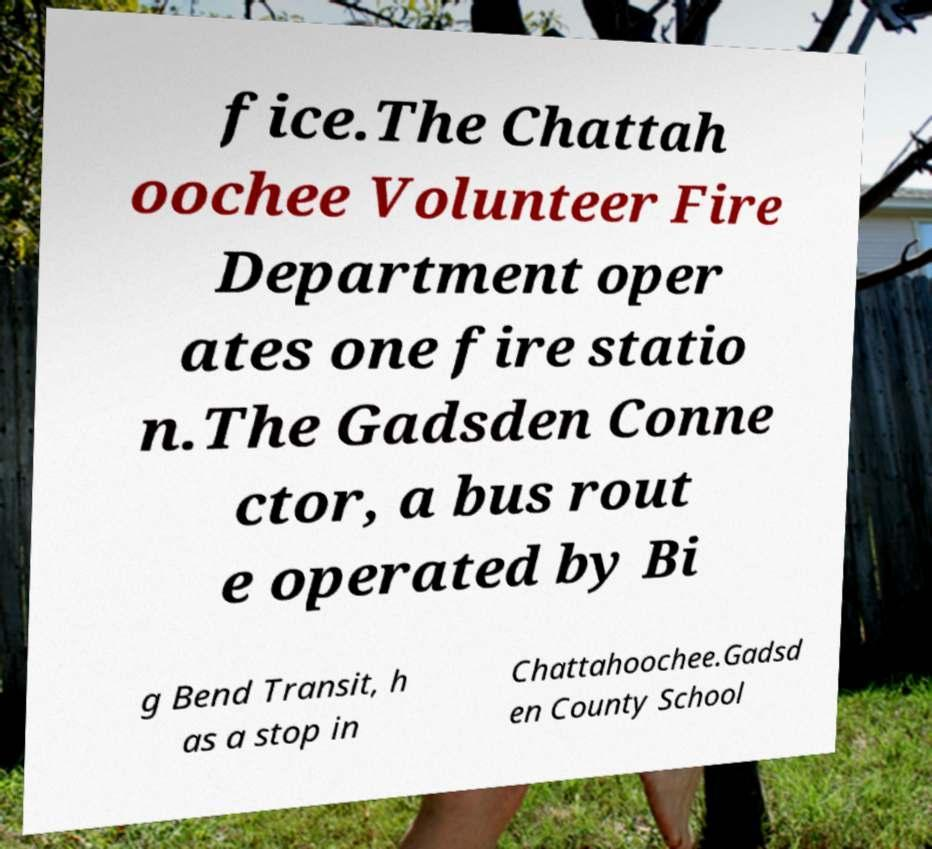What messages or text are displayed in this image? I need them in a readable, typed format. fice.The Chattah oochee Volunteer Fire Department oper ates one fire statio n.The Gadsden Conne ctor, a bus rout e operated by Bi g Bend Transit, h as a stop in Chattahoochee.Gadsd en County School 